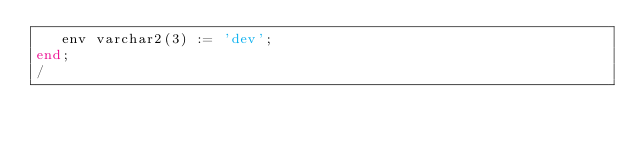<code> <loc_0><loc_0><loc_500><loc_500><_SQL_>   env varchar2(3) := 'dev';
end;
/
</code> 